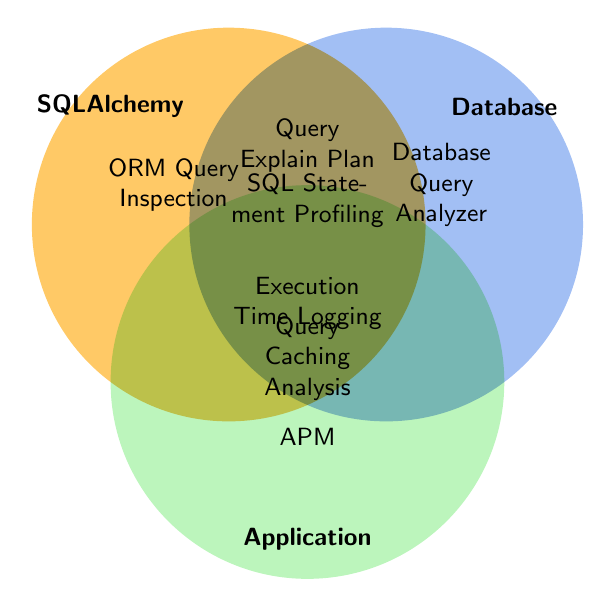Which methods overlap between SQLAlchemy and Database? From the figure, find where the SQLAlchemy and Database circles overlap. The methods in that section are the ones used by both.
Answer: Query Explain Plan, Execution Time Logging, SQL Statement Profiling, Query Caching Analysis Which methods are unique to the SQLAlchemy circle? Look for methods within the SQLAlchemy circle that don't overlap with Database or Application.
Answer: ORM Query Inspection Which method(s) are common to all three categories: SQLAlchemy, Database, and Application? Locate the overlapping section of all three circles, the method(s) in that shared region are used by all three categories.
Answer: Execution Time Logging, Query Caching Analysis Which methods are used in Database but not in SQLAlchemy? Identify the methods within the Database circle that do not overlap with the SQLAlchemy circle.
Answer: Database Query Analyzer Which methods are used by both Database and Application? Look for methods in the overlapping section between Database and Application.
Answer: Execution Time Logging, Query Caching Analysis 